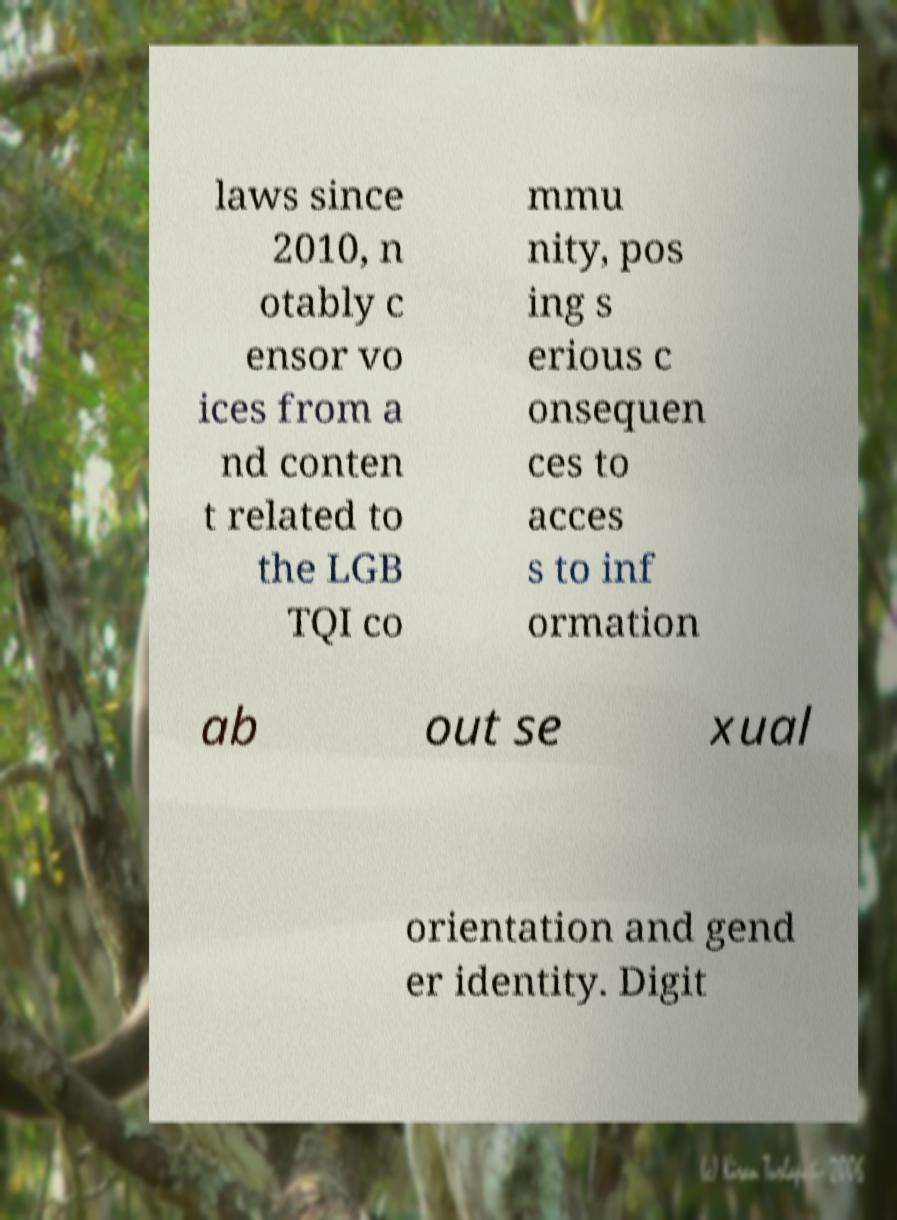Can you accurately transcribe the text from the provided image for me? laws since 2010, n otably c ensor vo ices from a nd conten t related to the LGB TQI co mmu nity, pos ing s erious c onsequen ces to acces s to inf ormation ab out se xual orientation and gend er identity. Digit 